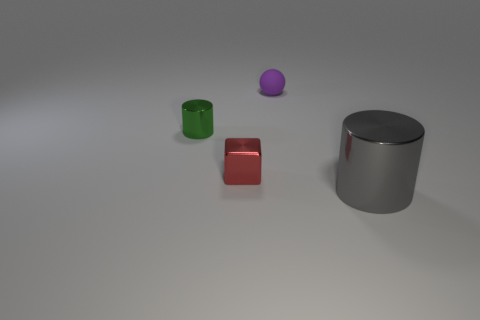Are there more purple rubber balls behind the red object than red rubber cylinders?
Your response must be concise. Yes. What number of rubber objects are small purple spheres or red blocks?
Offer a terse response. 1. There is a object that is on the right side of the red thing and on the left side of the big gray metallic cylinder; what is its size?
Give a very brief answer. Small. There is a shiny cylinder right of the tiny red metal thing; is there a metal cylinder that is left of it?
Make the answer very short. Yes. How many purple rubber balls are on the right side of the tiny red object?
Give a very brief answer. 1. What is the color of the big object that is the same shape as the small green metallic object?
Provide a succinct answer. Gray. Is the tiny thing that is in front of the green cylinder made of the same material as the tiny object that is on the right side of the tiny red cube?
Give a very brief answer. No. Do the sphere and the cylinder that is left of the cube have the same color?
Your answer should be very brief. No. The object that is on the right side of the red block and behind the big cylinder has what shape?
Your response must be concise. Sphere. What number of cyan matte blocks are there?
Offer a terse response. 0. 